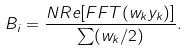<formula> <loc_0><loc_0><loc_500><loc_500>B _ { i } = \frac { N R e [ F F T ( w _ { k } y _ { k } ) ] } { \sum ( w _ { k } / 2 ) } .</formula> 